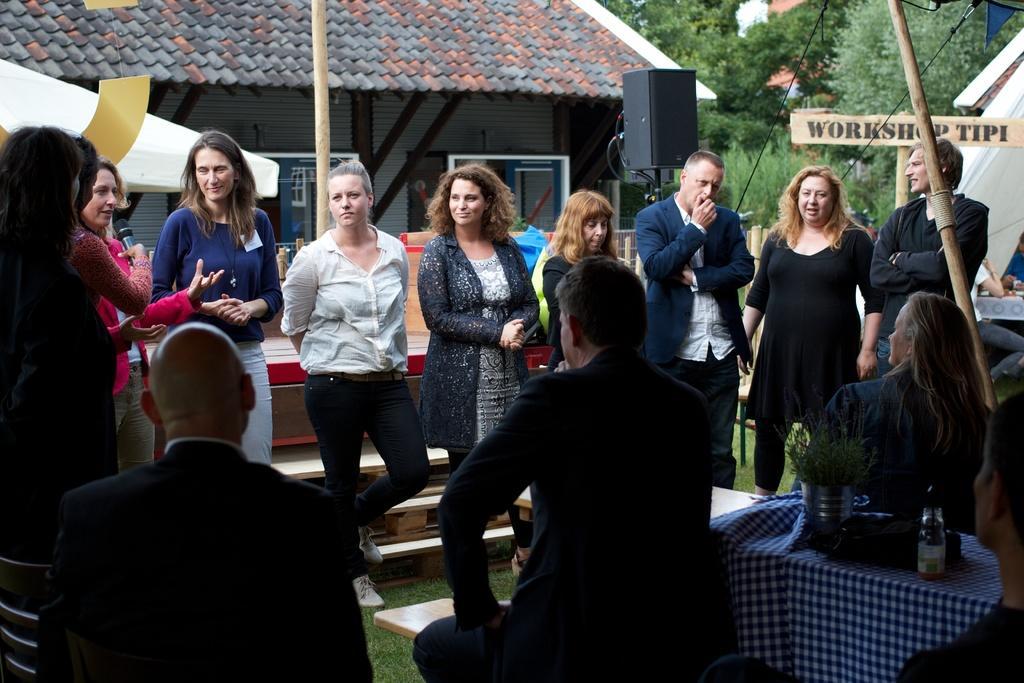In one or two sentences, can you explain what this image depicts? In the center of the image a group of people are standing. On the left side of the image a lady is standing and holding a mic. At the bottom of the image three persons are sitting on a chair and also we can see a table, bottle, cloth, flower pot are there. In the background of the image we can see speakers, poles, board, tent, house, trees, flag are there. At the bottom of the image ground is there. 